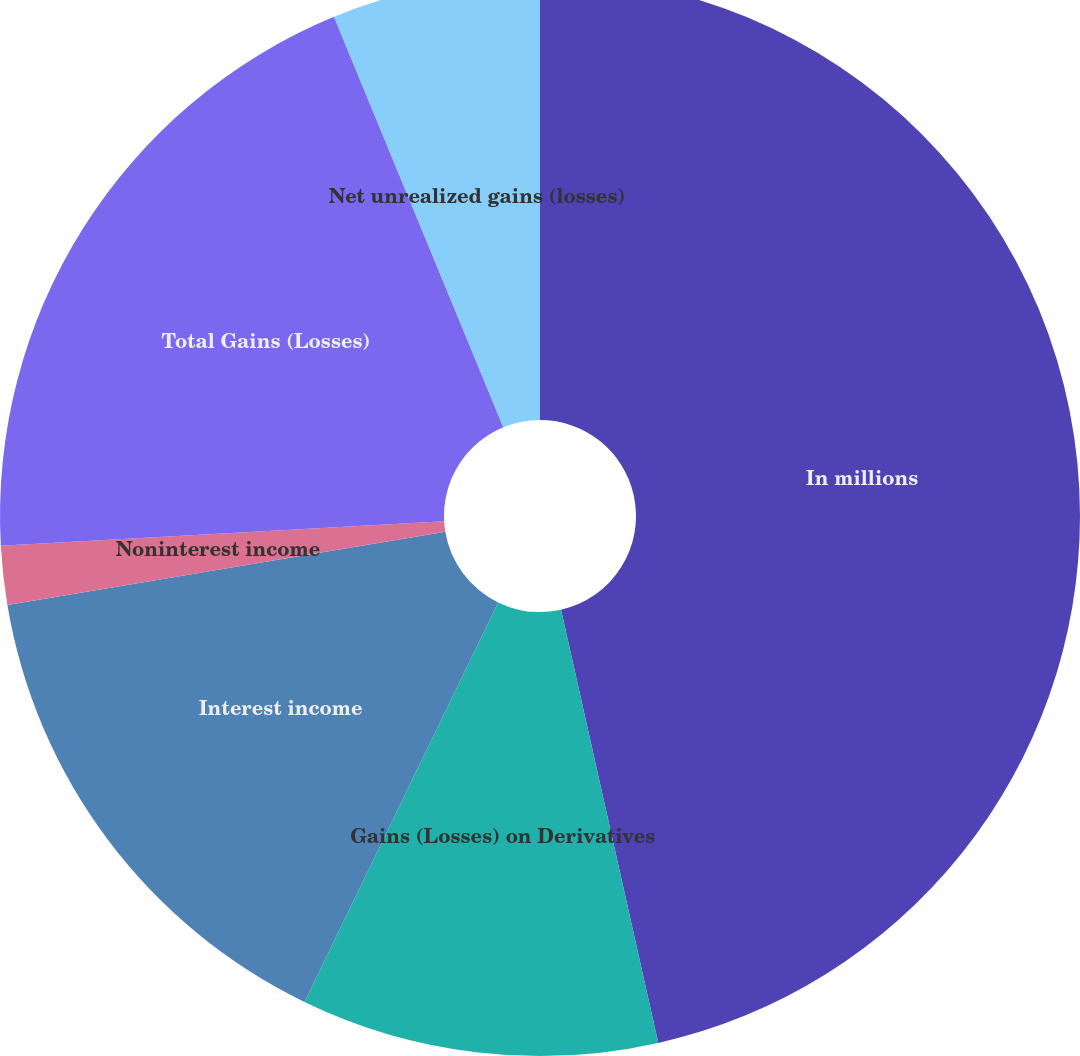Convert chart. <chart><loc_0><loc_0><loc_500><loc_500><pie_chart><fcel>In millions<fcel>Gains (Losses) on Derivatives<fcel>Interest income<fcel>Noninterest income<fcel>Total Gains (Losses)<fcel>Net unrealized gains (losses)<nl><fcel>46.49%<fcel>10.7%<fcel>15.18%<fcel>1.76%<fcel>19.65%<fcel>6.23%<nl></chart> 